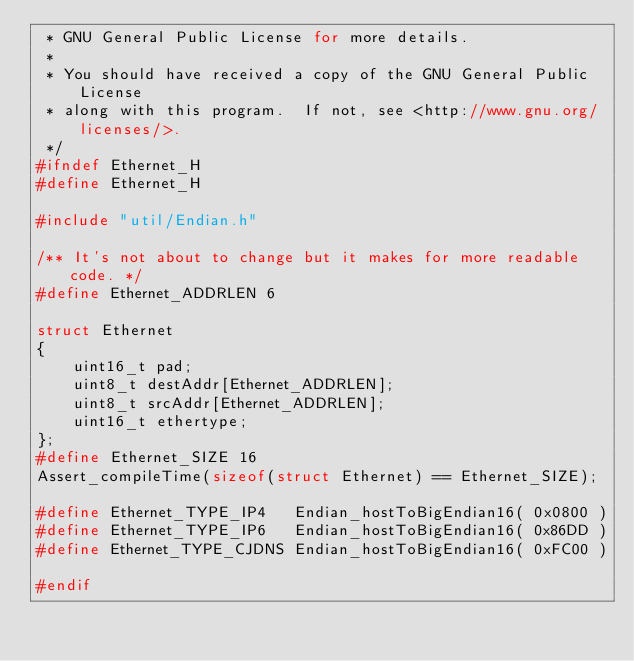<code> <loc_0><loc_0><loc_500><loc_500><_C_> * GNU General Public License for more details.
 *
 * You should have received a copy of the GNU General Public License
 * along with this program.  If not, see <http://www.gnu.org/licenses/>.
 */
#ifndef Ethernet_H
#define Ethernet_H

#include "util/Endian.h"

/** It's not about to change but it makes for more readable code. */
#define Ethernet_ADDRLEN 6

struct Ethernet
{
    uint16_t pad;
    uint8_t destAddr[Ethernet_ADDRLEN];
    uint8_t srcAddr[Ethernet_ADDRLEN];
    uint16_t ethertype;
};
#define Ethernet_SIZE 16
Assert_compileTime(sizeof(struct Ethernet) == Ethernet_SIZE);

#define Ethernet_TYPE_IP4   Endian_hostToBigEndian16( 0x0800 )
#define Ethernet_TYPE_IP6   Endian_hostToBigEndian16( 0x86DD )
#define Ethernet_TYPE_CJDNS Endian_hostToBigEndian16( 0xFC00 )

#endif
</code> 